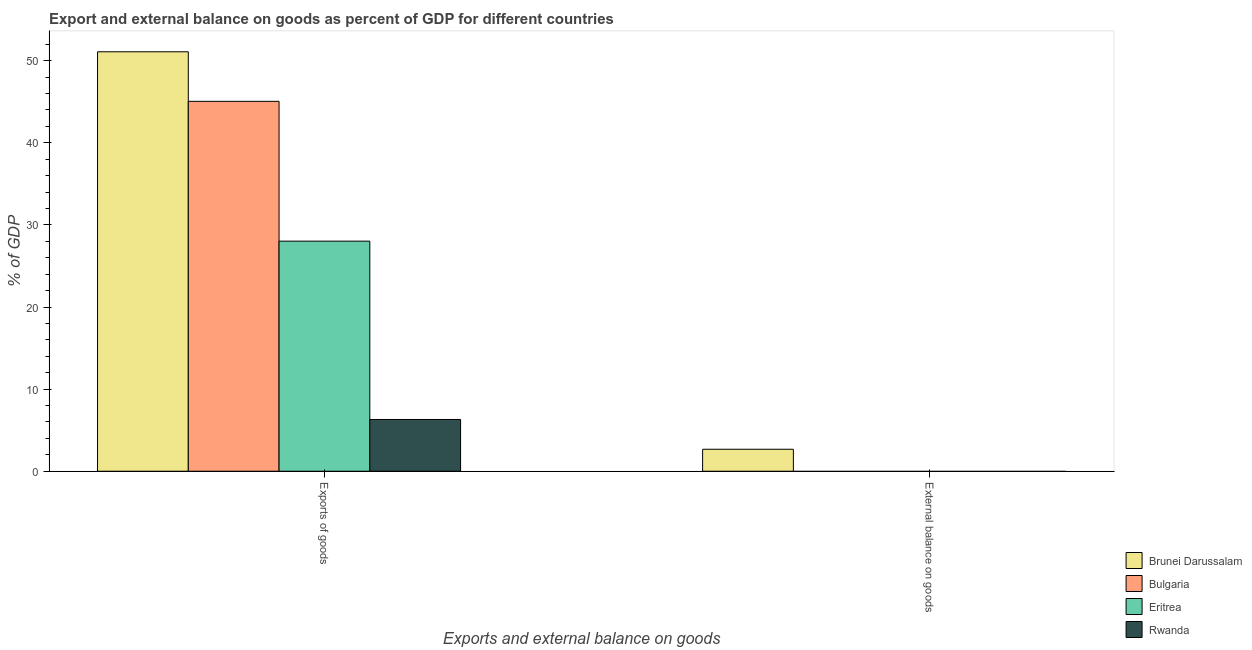How many different coloured bars are there?
Provide a short and direct response. 4. How many bars are there on the 1st tick from the right?
Offer a very short reply. 1. What is the label of the 1st group of bars from the left?
Your response must be concise. Exports of goods. What is the external balance on goods as percentage of gdp in Brunei Darussalam?
Ensure brevity in your answer.  2.67. Across all countries, what is the maximum export of goods as percentage of gdp?
Give a very brief answer. 51.08. Across all countries, what is the minimum export of goods as percentage of gdp?
Your response must be concise. 6.3. In which country was the external balance on goods as percentage of gdp maximum?
Provide a short and direct response. Brunei Darussalam. What is the total export of goods as percentage of gdp in the graph?
Your answer should be compact. 130.45. What is the difference between the export of goods as percentage of gdp in Rwanda and that in Eritrea?
Your answer should be compact. -21.72. What is the difference between the external balance on goods as percentage of gdp in Brunei Darussalam and the export of goods as percentage of gdp in Bulgaria?
Give a very brief answer. -42.37. What is the average export of goods as percentage of gdp per country?
Keep it short and to the point. 32.61. What is the difference between the external balance on goods as percentage of gdp and export of goods as percentage of gdp in Brunei Darussalam?
Your response must be concise. -48.41. What is the ratio of the export of goods as percentage of gdp in Rwanda to that in Eritrea?
Provide a succinct answer. 0.22. Is the export of goods as percentage of gdp in Brunei Darussalam less than that in Bulgaria?
Your answer should be compact. No. How many bars are there?
Provide a short and direct response. 5. Are all the bars in the graph horizontal?
Provide a succinct answer. No. Are the values on the major ticks of Y-axis written in scientific E-notation?
Provide a succinct answer. No. Does the graph contain any zero values?
Offer a terse response. Yes. Does the graph contain grids?
Your answer should be very brief. No. Where does the legend appear in the graph?
Provide a short and direct response. Bottom right. How many legend labels are there?
Offer a terse response. 4. What is the title of the graph?
Offer a very short reply. Export and external balance on goods as percent of GDP for different countries. Does "Romania" appear as one of the legend labels in the graph?
Provide a short and direct response. No. What is the label or title of the X-axis?
Your answer should be compact. Exports and external balance on goods. What is the label or title of the Y-axis?
Offer a terse response. % of GDP. What is the % of GDP of Brunei Darussalam in Exports of goods?
Provide a succinct answer. 51.08. What is the % of GDP of Bulgaria in Exports of goods?
Your answer should be very brief. 45.05. What is the % of GDP in Eritrea in Exports of goods?
Offer a terse response. 28.02. What is the % of GDP in Rwanda in Exports of goods?
Offer a very short reply. 6.3. What is the % of GDP of Brunei Darussalam in External balance on goods?
Your response must be concise. 2.67. What is the % of GDP in Eritrea in External balance on goods?
Your answer should be compact. 0. What is the % of GDP of Rwanda in External balance on goods?
Keep it short and to the point. 0. Across all Exports and external balance on goods, what is the maximum % of GDP of Brunei Darussalam?
Offer a very short reply. 51.08. Across all Exports and external balance on goods, what is the maximum % of GDP in Bulgaria?
Keep it short and to the point. 45.05. Across all Exports and external balance on goods, what is the maximum % of GDP in Eritrea?
Your answer should be very brief. 28.02. Across all Exports and external balance on goods, what is the maximum % of GDP of Rwanda?
Your response must be concise. 6.3. Across all Exports and external balance on goods, what is the minimum % of GDP of Brunei Darussalam?
Ensure brevity in your answer.  2.67. Across all Exports and external balance on goods, what is the minimum % of GDP of Bulgaria?
Make the answer very short. 0. Across all Exports and external balance on goods, what is the minimum % of GDP in Eritrea?
Your answer should be compact. 0. Across all Exports and external balance on goods, what is the minimum % of GDP of Rwanda?
Give a very brief answer. 0. What is the total % of GDP in Brunei Darussalam in the graph?
Provide a succinct answer. 53.76. What is the total % of GDP in Bulgaria in the graph?
Keep it short and to the point. 45.05. What is the total % of GDP in Eritrea in the graph?
Your response must be concise. 28.02. What is the total % of GDP in Rwanda in the graph?
Offer a terse response. 6.3. What is the difference between the % of GDP of Brunei Darussalam in Exports of goods and that in External balance on goods?
Your answer should be compact. 48.41. What is the average % of GDP of Brunei Darussalam per Exports and external balance on goods?
Provide a succinct answer. 26.88. What is the average % of GDP of Bulgaria per Exports and external balance on goods?
Offer a terse response. 22.52. What is the average % of GDP in Eritrea per Exports and external balance on goods?
Provide a succinct answer. 14.01. What is the average % of GDP in Rwanda per Exports and external balance on goods?
Keep it short and to the point. 3.15. What is the difference between the % of GDP of Brunei Darussalam and % of GDP of Bulgaria in Exports of goods?
Your response must be concise. 6.03. What is the difference between the % of GDP of Brunei Darussalam and % of GDP of Eritrea in Exports of goods?
Ensure brevity in your answer.  23.06. What is the difference between the % of GDP of Brunei Darussalam and % of GDP of Rwanda in Exports of goods?
Your answer should be compact. 44.78. What is the difference between the % of GDP in Bulgaria and % of GDP in Eritrea in Exports of goods?
Your answer should be very brief. 17.03. What is the difference between the % of GDP of Bulgaria and % of GDP of Rwanda in Exports of goods?
Provide a succinct answer. 38.74. What is the difference between the % of GDP of Eritrea and % of GDP of Rwanda in Exports of goods?
Make the answer very short. 21.72. What is the ratio of the % of GDP in Brunei Darussalam in Exports of goods to that in External balance on goods?
Your response must be concise. 19.1. What is the difference between the highest and the second highest % of GDP of Brunei Darussalam?
Provide a short and direct response. 48.41. What is the difference between the highest and the lowest % of GDP in Brunei Darussalam?
Give a very brief answer. 48.41. What is the difference between the highest and the lowest % of GDP of Bulgaria?
Your response must be concise. 45.05. What is the difference between the highest and the lowest % of GDP in Eritrea?
Offer a terse response. 28.02. What is the difference between the highest and the lowest % of GDP of Rwanda?
Your answer should be very brief. 6.3. 